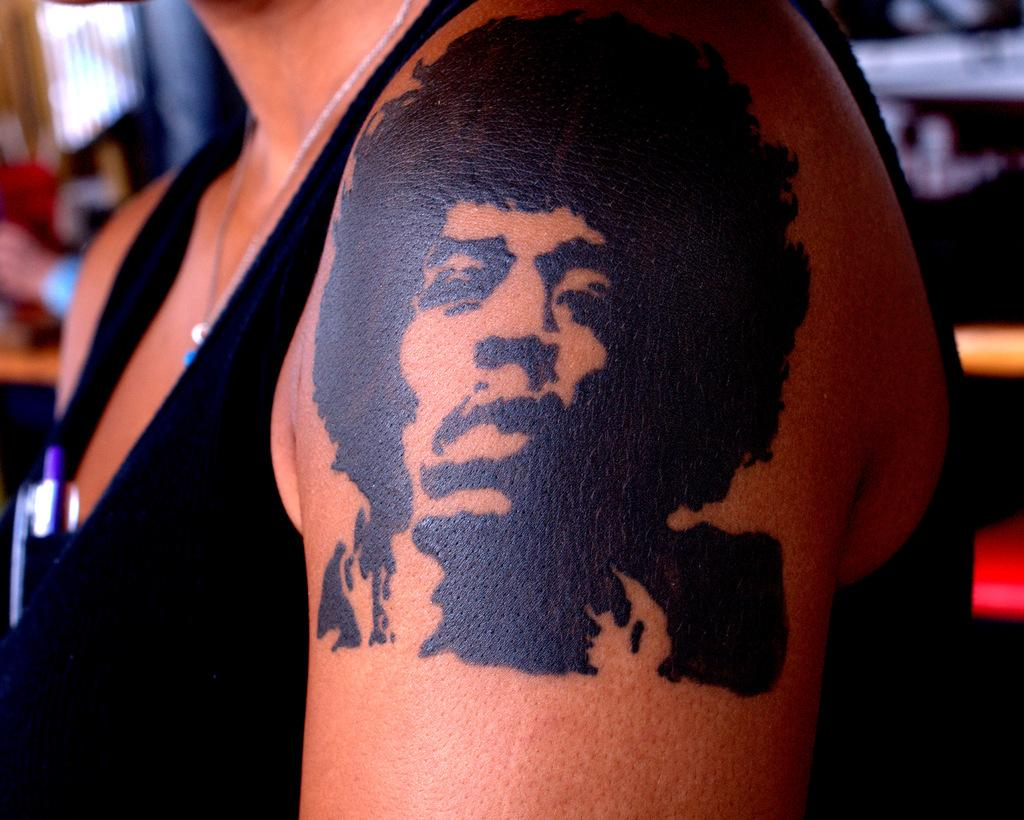What is present in the image? There is a person in the image. Can you describe the person's attire? The person is wearing a black dress. Are there any visible accessories or features on the person? Yes, the person has a tattoo on their arm. What type of calculator is the person using in the image? There is no calculator present in the image. What division is the person performing in the image? There is no division or mathematical activity taking place in the image. 